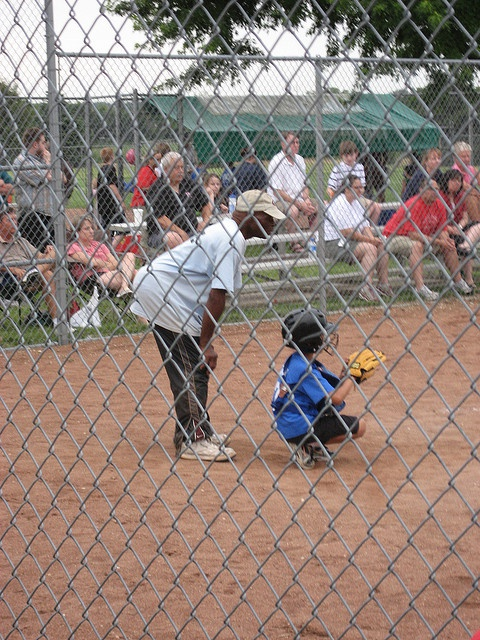Describe the objects in this image and their specific colors. I can see people in lightgray, gray, darkgray, and black tones, people in lightgray, darkgray, black, and gray tones, people in lightgray, black, gray, blue, and darkgray tones, people in lightgray, gray, darkgray, and lavender tones, and bench in lightgray, gray, and darkgray tones in this image. 